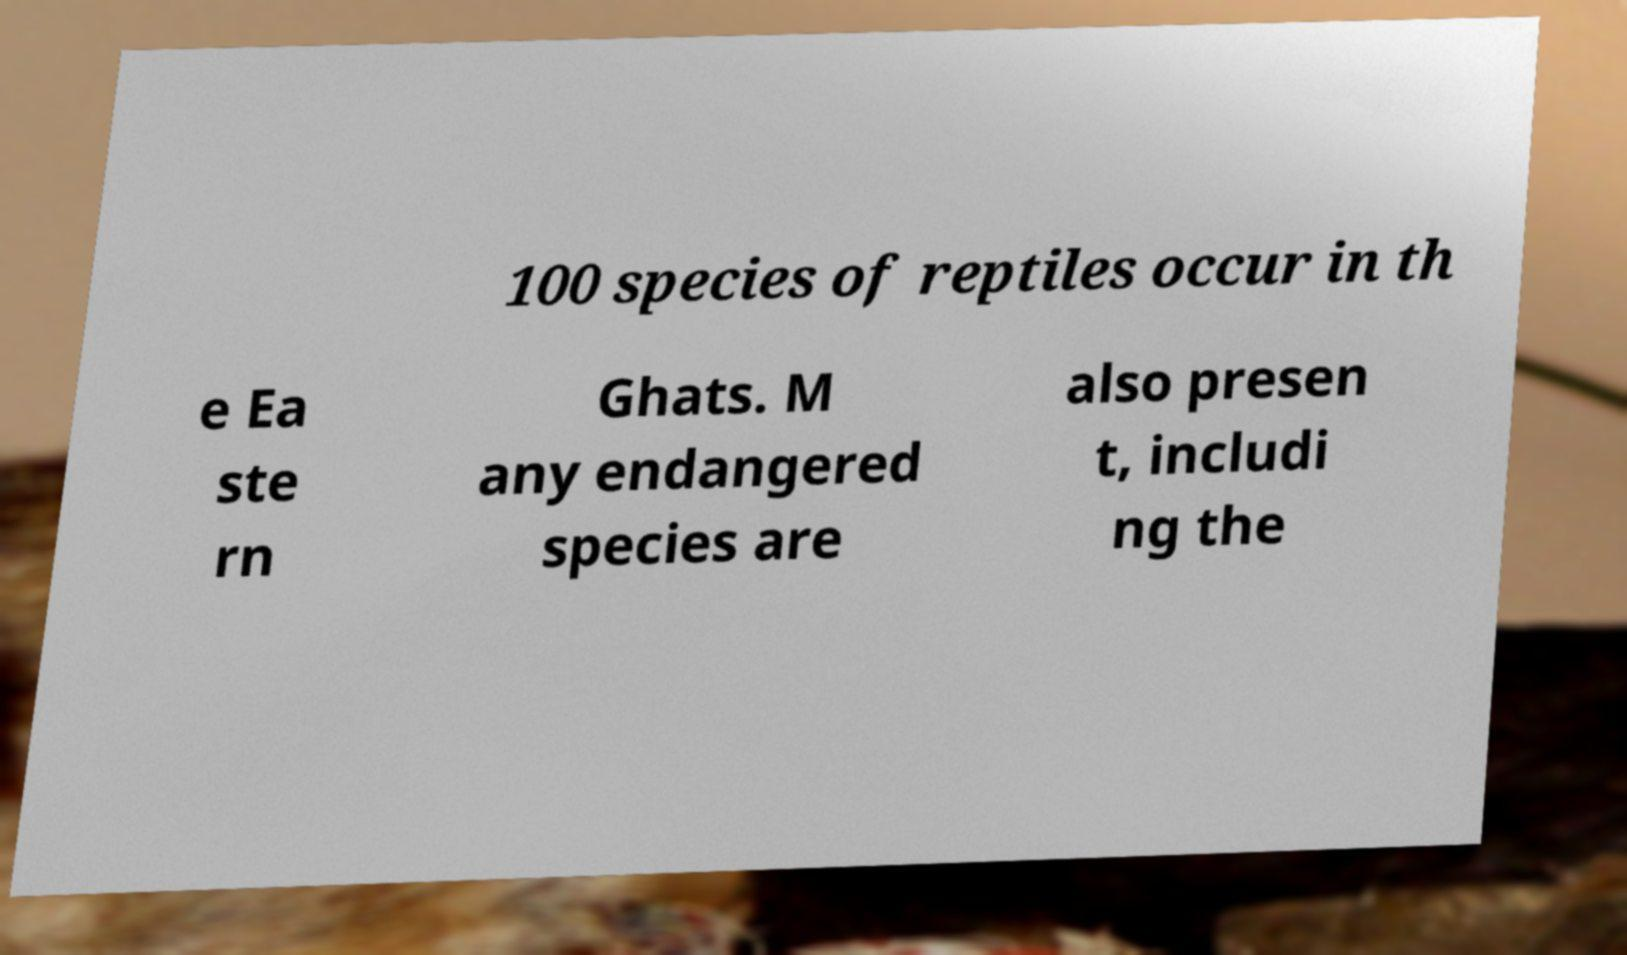Please read and relay the text visible in this image. What does it say? 100 species of reptiles occur in th e Ea ste rn Ghats. M any endangered species are also presen t, includi ng the 